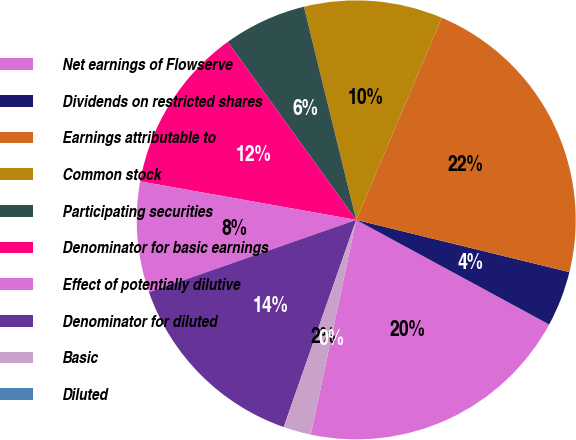Convert chart. <chart><loc_0><loc_0><loc_500><loc_500><pie_chart><fcel>Net earnings of Flowserve<fcel>Dividends on restricted shares<fcel>Earnings attributable to<fcel>Common stock<fcel>Participating securities<fcel>Denominator for basic earnings<fcel>Effect of potentially dilutive<fcel>Denominator for diluted<fcel>Basic<fcel>Diluted<nl><fcel>20.41%<fcel>4.08%<fcel>22.45%<fcel>10.2%<fcel>6.12%<fcel>12.24%<fcel>8.16%<fcel>14.29%<fcel>2.04%<fcel>0.0%<nl></chart> 